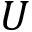Convert formula to latex. <formula><loc_0><loc_0><loc_500><loc_500>U</formula> 